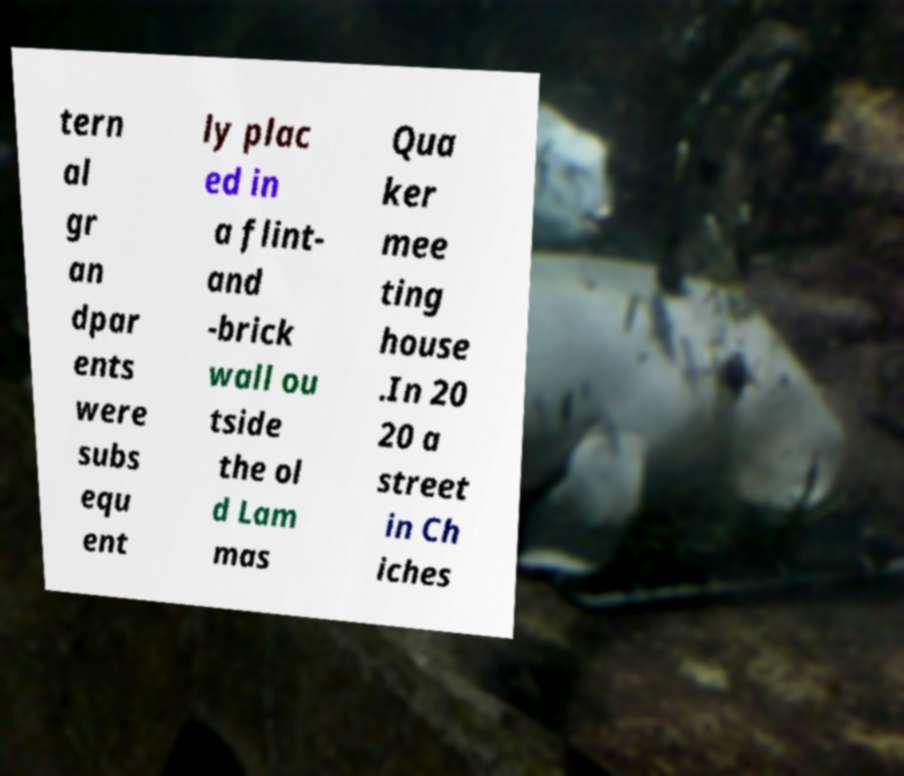Can you read and provide the text displayed in the image?This photo seems to have some interesting text. Can you extract and type it out for me? tern al gr an dpar ents were subs equ ent ly plac ed in a flint- and -brick wall ou tside the ol d Lam mas Qua ker mee ting house .In 20 20 a street in Ch iches 